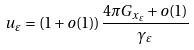<formula> <loc_0><loc_0><loc_500><loc_500>u _ { \varepsilon } = ( 1 + o ( 1 ) ) \frac { 4 \pi G _ { x _ { \varepsilon } } + o ( 1 ) } { \gamma _ { \varepsilon } }</formula> 